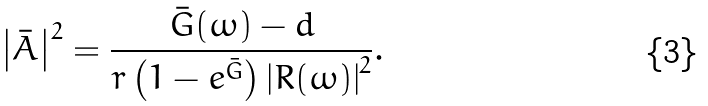Convert formula to latex. <formula><loc_0><loc_0><loc_500><loc_500>\left | \bar { A } \right | ^ { 2 } = \frac { \bar { G } ( \omega ) - d } { r \left ( 1 - e ^ { \bar { G } } \right ) \left | R ( \omega ) \right | ^ { 2 } } .</formula> 